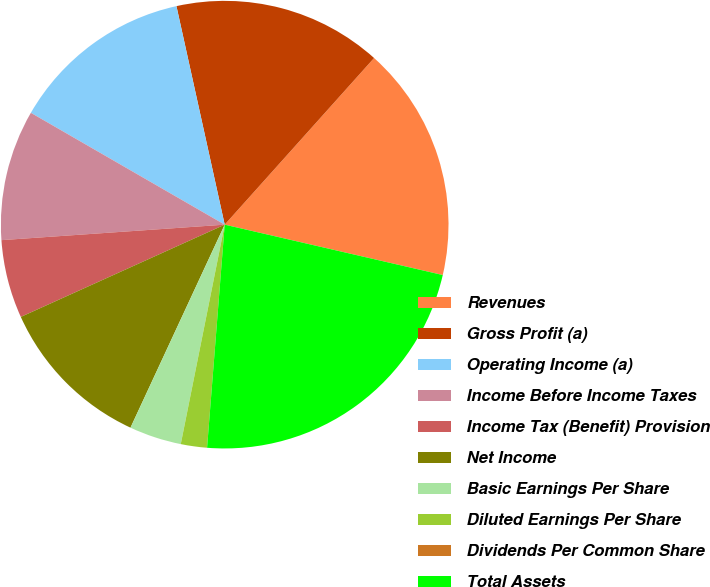<chart> <loc_0><loc_0><loc_500><loc_500><pie_chart><fcel>Revenues<fcel>Gross Profit (a)<fcel>Operating Income (a)<fcel>Income Before Income Taxes<fcel>Income Tax (Benefit) Provision<fcel>Net Income<fcel>Basic Earnings Per Share<fcel>Diluted Earnings Per Share<fcel>Dividends Per Common Share<fcel>Total Assets<nl><fcel>16.98%<fcel>15.09%<fcel>13.21%<fcel>9.43%<fcel>5.66%<fcel>11.32%<fcel>3.77%<fcel>1.89%<fcel>0.0%<fcel>22.64%<nl></chart> 